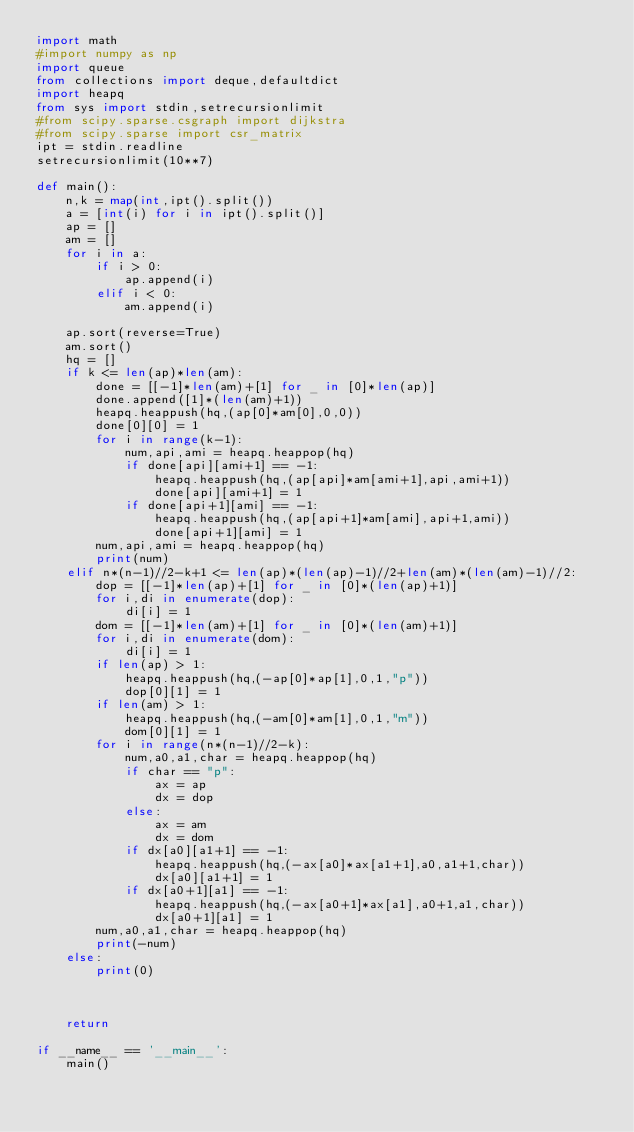Convert code to text. <code><loc_0><loc_0><loc_500><loc_500><_Python_>import math
#import numpy as np
import queue
from collections import deque,defaultdict
import heapq
from sys import stdin,setrecursionlimit
#from scipy.sparse.csgraph import dijkstra
#from scipy.sparse import csr_matrix
ipt = stdin.readline
setrecursionlimit(10**7)

def main():
    n,k = map(int,ipt().split())
    a = [int(i) for i in ipt().split()]
    ap = []
    am = []
    for i in a:
        if i > 0:
            ap.append(i)
        elif i < 0:
            am.append(i)

    ap.sort(reverse=True)
    am.sort()
    hq = []
    if k <= len(ap)*len(am):
        done = [[-1]*len(am)+[1] for _ in [0]*len(ap)]
        done.append([1]*(len(am)+1))
        heapq.heappush(hq,(ap[0]*am[0],0,0))
        done[0][0] = 1
        for i in range(k-1):
            num,api,ami = heapq.heappop(hq)
            if done[api][ami+1] == -1:
                heapq.heappush(hq,(ap[api]*am[ami+1],api,ami+1))
                done[api][ami+1] = 1
            if done[api+1][ami] == -1:
                heapq.heappush(hq,(ap[api+1]*am[ami],api+1,ami))
                done[api+1][ami] = 1
        num,api,ami = heapq.heappop(hq)
        print(num)
    elif n*(n-1)//2-k+1 <= len(ap)*(len(ap)-1)//2+len(am)*(len(am)-1)//2:
        dop = [[-1]*len(ap)+[1] for _ in [0]*(len(ap)+1)]
        for i,di in enumerate(dop):
            di[i] = 1
        dom = [[-1]*len(am)+[1] for _ in [0]*(len(am)+1)]
        for i,di in enumerate(dom):
            di[i] = 1
        if len(ap) > 1:
            heapq.heappush(hq,(-ap[0]*ap[1],0,1,"p"))
            dop[0][1] = 1
        if len(am) > 1:
            heapq.heappush(hq,(-am[0]*am[1],0,1,"m"))
            dom[0][1] = 1
        for i in range(n*(n-1)//2-k):
            num,a0,a1,char = heapq.heappop(hq)
            if char == "p":
                ax = ap
                dx = dop
            else:
                ax = am
                dx = dom
            if dx[a0][a1+1] == -1:
                heapq.heappush(hq,(-ax[a0]*ax[a1+1],a0,a1+1,char))
                dx[a0][a1+1] = 1
            if dx[a0+1][a1] == -1:
                heapq.heappush(hq,(-ax[a0+1]*ax[a1],a0+1,a1,char))
                dx[a0+1][a1] = 1
        num,a0,a1,char = heapq.heappop(hq)
        print(-num)
    else:
        print(0)



    return

if __name__ == '__main__':
    main()
</code> 